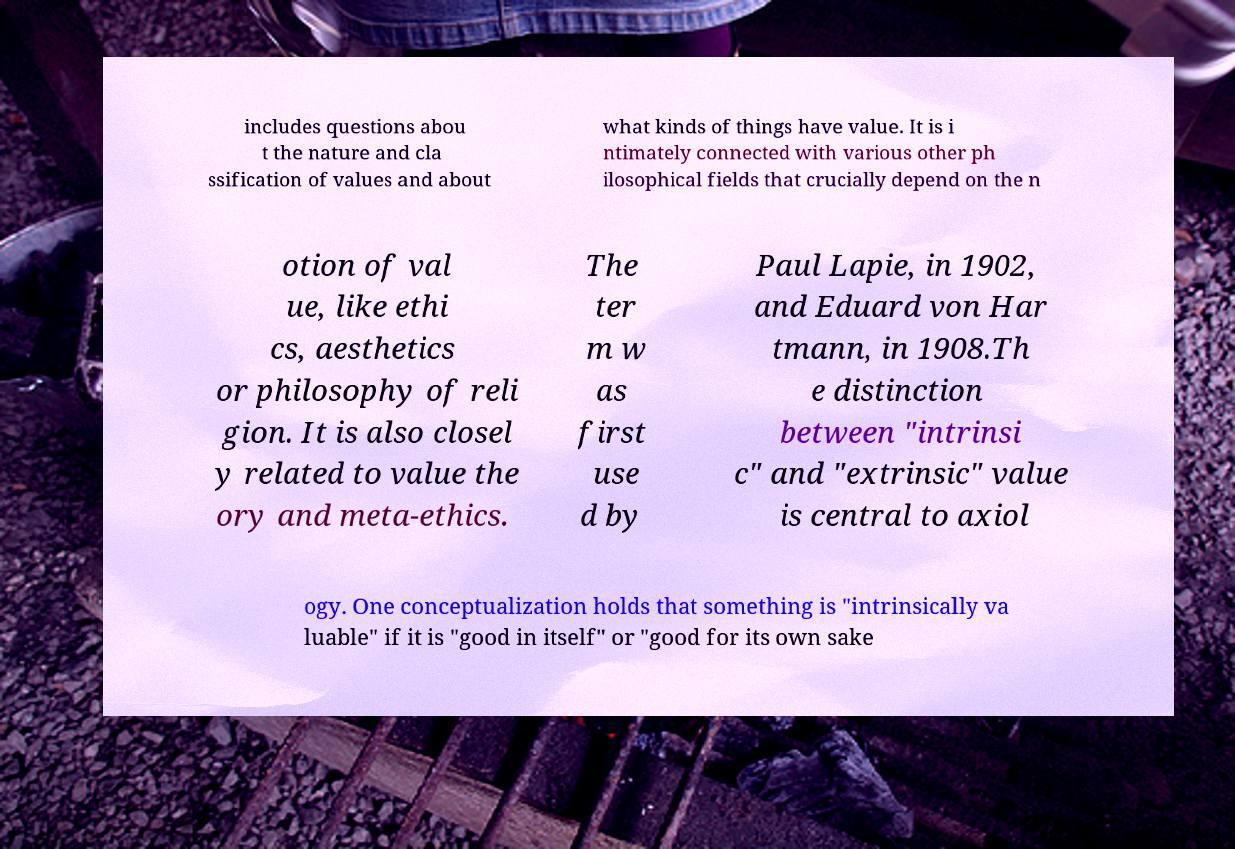Can you read and provide the text displayed in the image?This photo seems to have some interesting text. Can you extract and type it out for me? includes questions abou t the nature and cla ssification of values and about what kinds of things have value. It is i ntimately connected with various other ph ilosophical fields that crucially depend on the n otion of val ue, like ethi cs, aesthetics or philosophy of reli gion. It is also closel y related to value the ory and meta-ethics. The ter m w as first use d by Paul Lapie, in 1902, and Eduard von Har tmann, in 1908.Th e distinction between "intrinsi c" and "extrinsic" value is central to axiol ogy. One conceptualization holds that something is "intrinsically va luable" if it is "good in itself" or "good for its own sake 